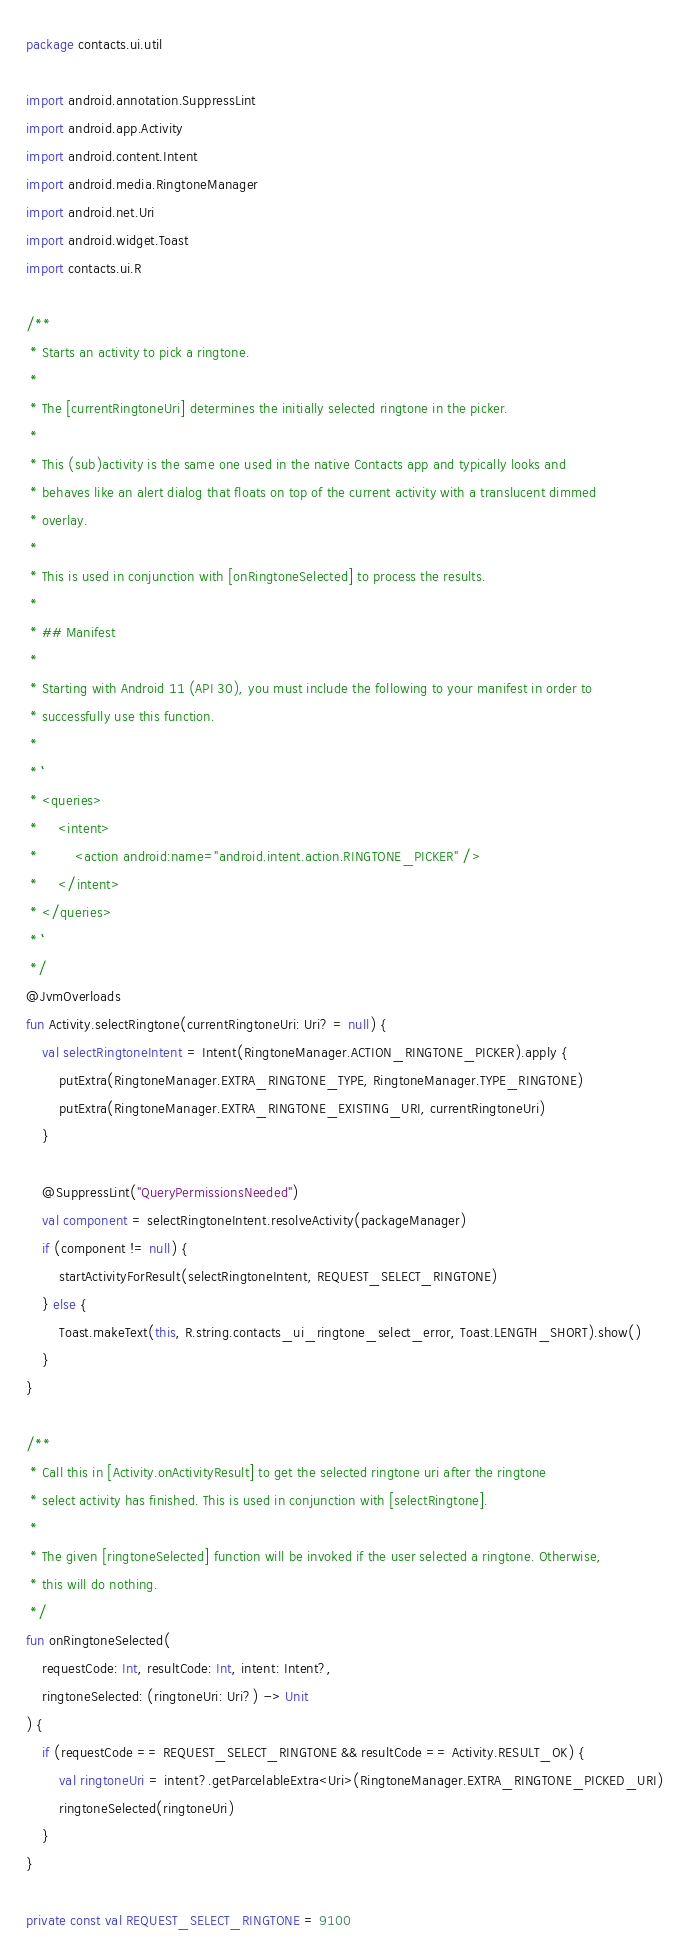Convert code to text. <code><loc_0><loc_0><loc_500><loc_500><_Kotlin_>package contacts.ui.util

import android.annotation.SuppressLint
import android.app.Activity
import android.content.Intent
import android.media.RingtoneManager
import android.net.Uri
import android.widget.Toast
import contacts.ui.R

/**
 * Starts an activity to pick a ringtone.
 *
 * The [currentRingtoneUri] determines the initially selected ringtone in the picker.
 *
 * This (sub)activity is the same one used in the native Contacts app and typically looks and
 * behaves like an alert dialog that floats on top of the current activity with a translucent dimmed
 * overlay.
 *
 * This is used in conjunction with [onRingtoneSelected] to process the results.
 *
 * ## Manifest
 *
 * Starting with Android 11 (API 30), you must include the following to your manifest in order to
 * successfully use this function.
 *
 * ```
 * <queries>
 *     <intent>
 *         <action android:name="android.intent.action.RINGTONE_PICKER" />
 *     </intent>
 * </queries>
 * ```
 */
@JvmOverloads
fun Activity.selectRingtone(currentRingtoneUri: Uri? = null) {
    val selectRingtoneIntent = Intent(RingtoneManager.ACTION_RINGTONE_PICKER).apply {
        putExtra(RingtoneManager.EXTRA_RINGTONE_TYPE, RingtoneManager.TYPE_RINGTONE)
        putExtra(RingtoneManager.EXTRA_RINGTONE_EXISTING_URI, currentRingtoneUri)
    }

    @SuppressLint("QueryPermissionsNeeded")
    val component = selectRingtoneIntent.resolveActivity(packageManager)
    if (component != null) {
        startActivityForResult(selectRingtoneIntent, REQUEST_SELECT_RINGTONE)
    } else {
        Toast.makeText(this, R.string.contacts_ui_ringtone_select_error, Toast.LENGTH_SHORT).show()
    }
}

/**
 * Call this in [Activity.onActivityResult] to get the selected ringtone uri after the ringtone
 * select activity has finished. This is used in conjunction with [selectRingtone].
 *
 * The given [ringtoneSelected] function will be invoked if the user selected a ringtone. Otherwise,
 * this will do nothing.
 */
fun onRingtoneSelected(
    requestCode: Int, resultCode: Int, intent: Intent?,
    ringtoneSelected: (ringtoneUri: Uri?) -> Unit
) {
    if (requestCode == REQUEST_SELECT_RINGTONE && resultCode == Activity.RESULT_OK) {
        val ringtoneUri = intent?.getParcelableExtra<Uri>(RingtoneManager.EXTRA_RINGTONE_PICKED_URI)
        ringtoneSelected(ringtoneUri)
    }
}

private const val REQUEST_SELECT_RINGTONE = 9100</code> 